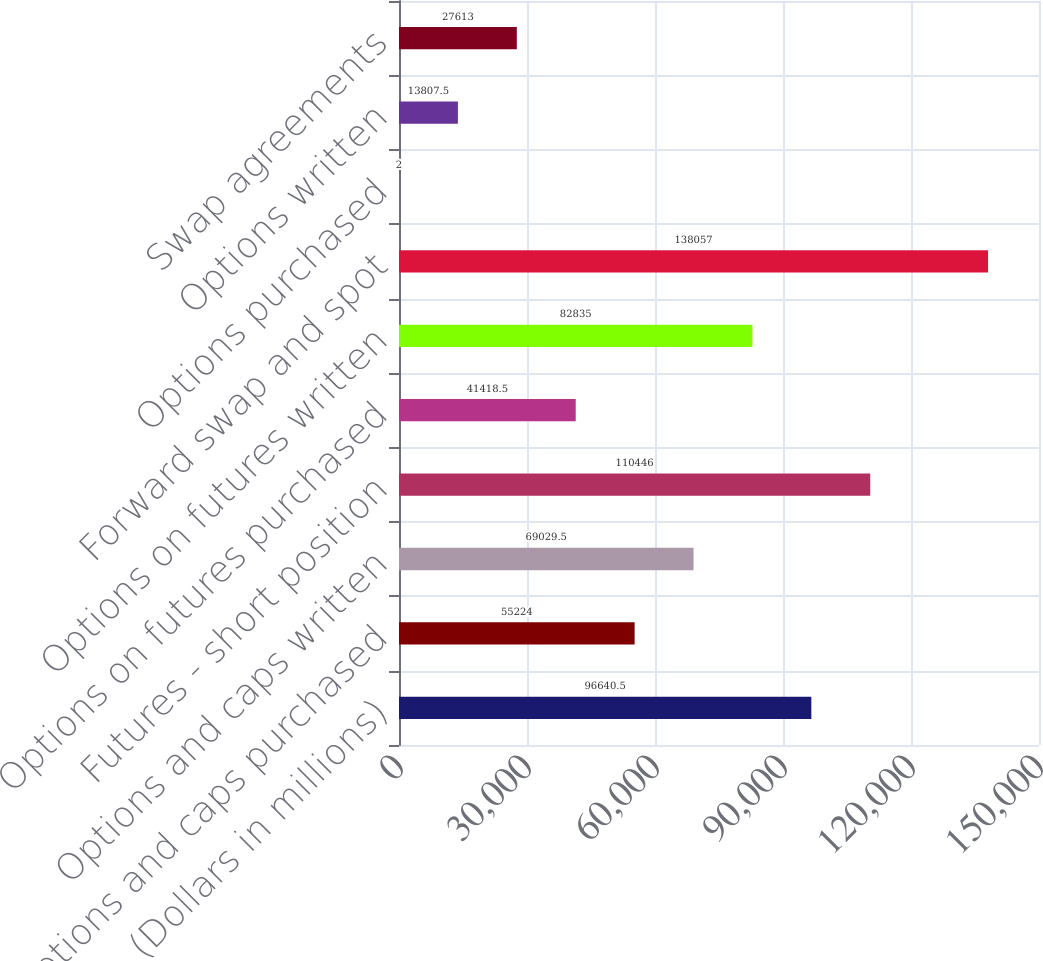Convert chart to OTSL. <chart><loc_0><loc_0><loc_500><loc_500><bar_chart><fcel>(Dollars in millions)<fcel>Options and caps purchased<fcel>Options and caps written<fcel>Futures - short position<fcel>Options on futures purchased<fcel>Options on futures written<fcel>Forward swap and spot<fcel>Options purchased<fcel>Options written<fcel>Swap agreements<nl><fcel>96640.5<fcel>55224<fcel>69029.5<fcel>110446<fcel>41418.5<fcel>82835<fcel>138057<fcel>2<fcel>13807.5<fcel>27613<nl></chart> 